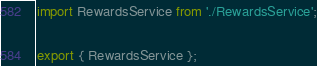<code> <loc_0><loc_0><loc_500><loc_500><_JavaScript_>import RewardsService from './RewardsService';

export { RewardsService };
</code> 